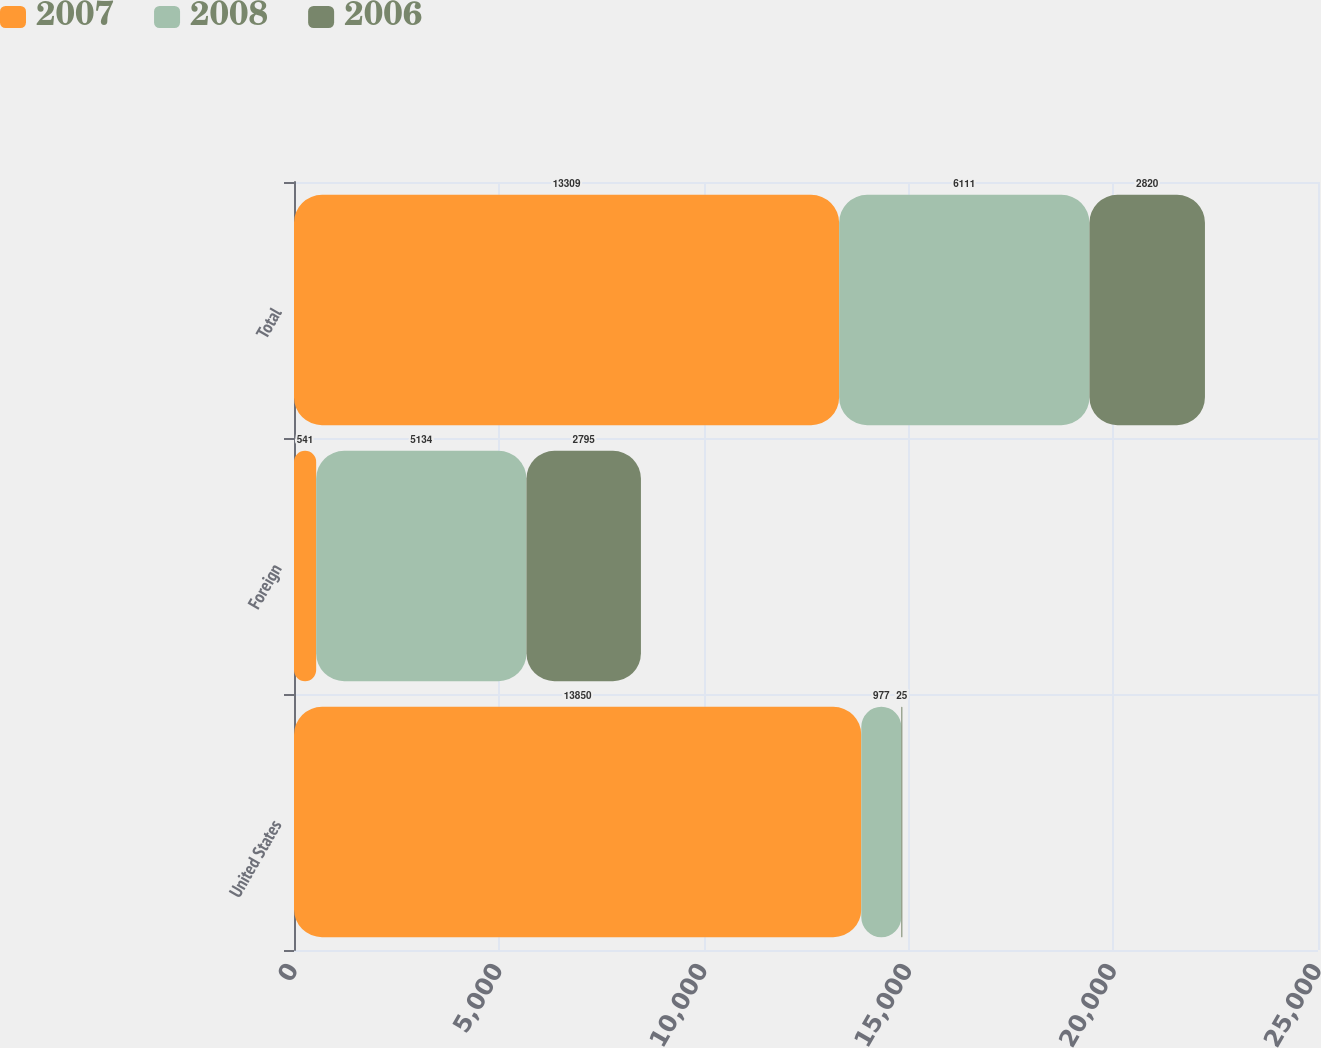Convert chart to OTSL. <chart><loc_0><loc_0><loc_500><loc_500><stacked_bar_chart><ecel><fcel>United States<fcel>Foreign<fcel>Total<nl><fcel>2007<fcel>13850<fcel>541<fcel>13309<nl><fcel>2008<fcel>977<fcel>5134<fcel>6111<nl><fcel>2006<fcel>25<fcel>2795<fcel>2820<nl></chart> 